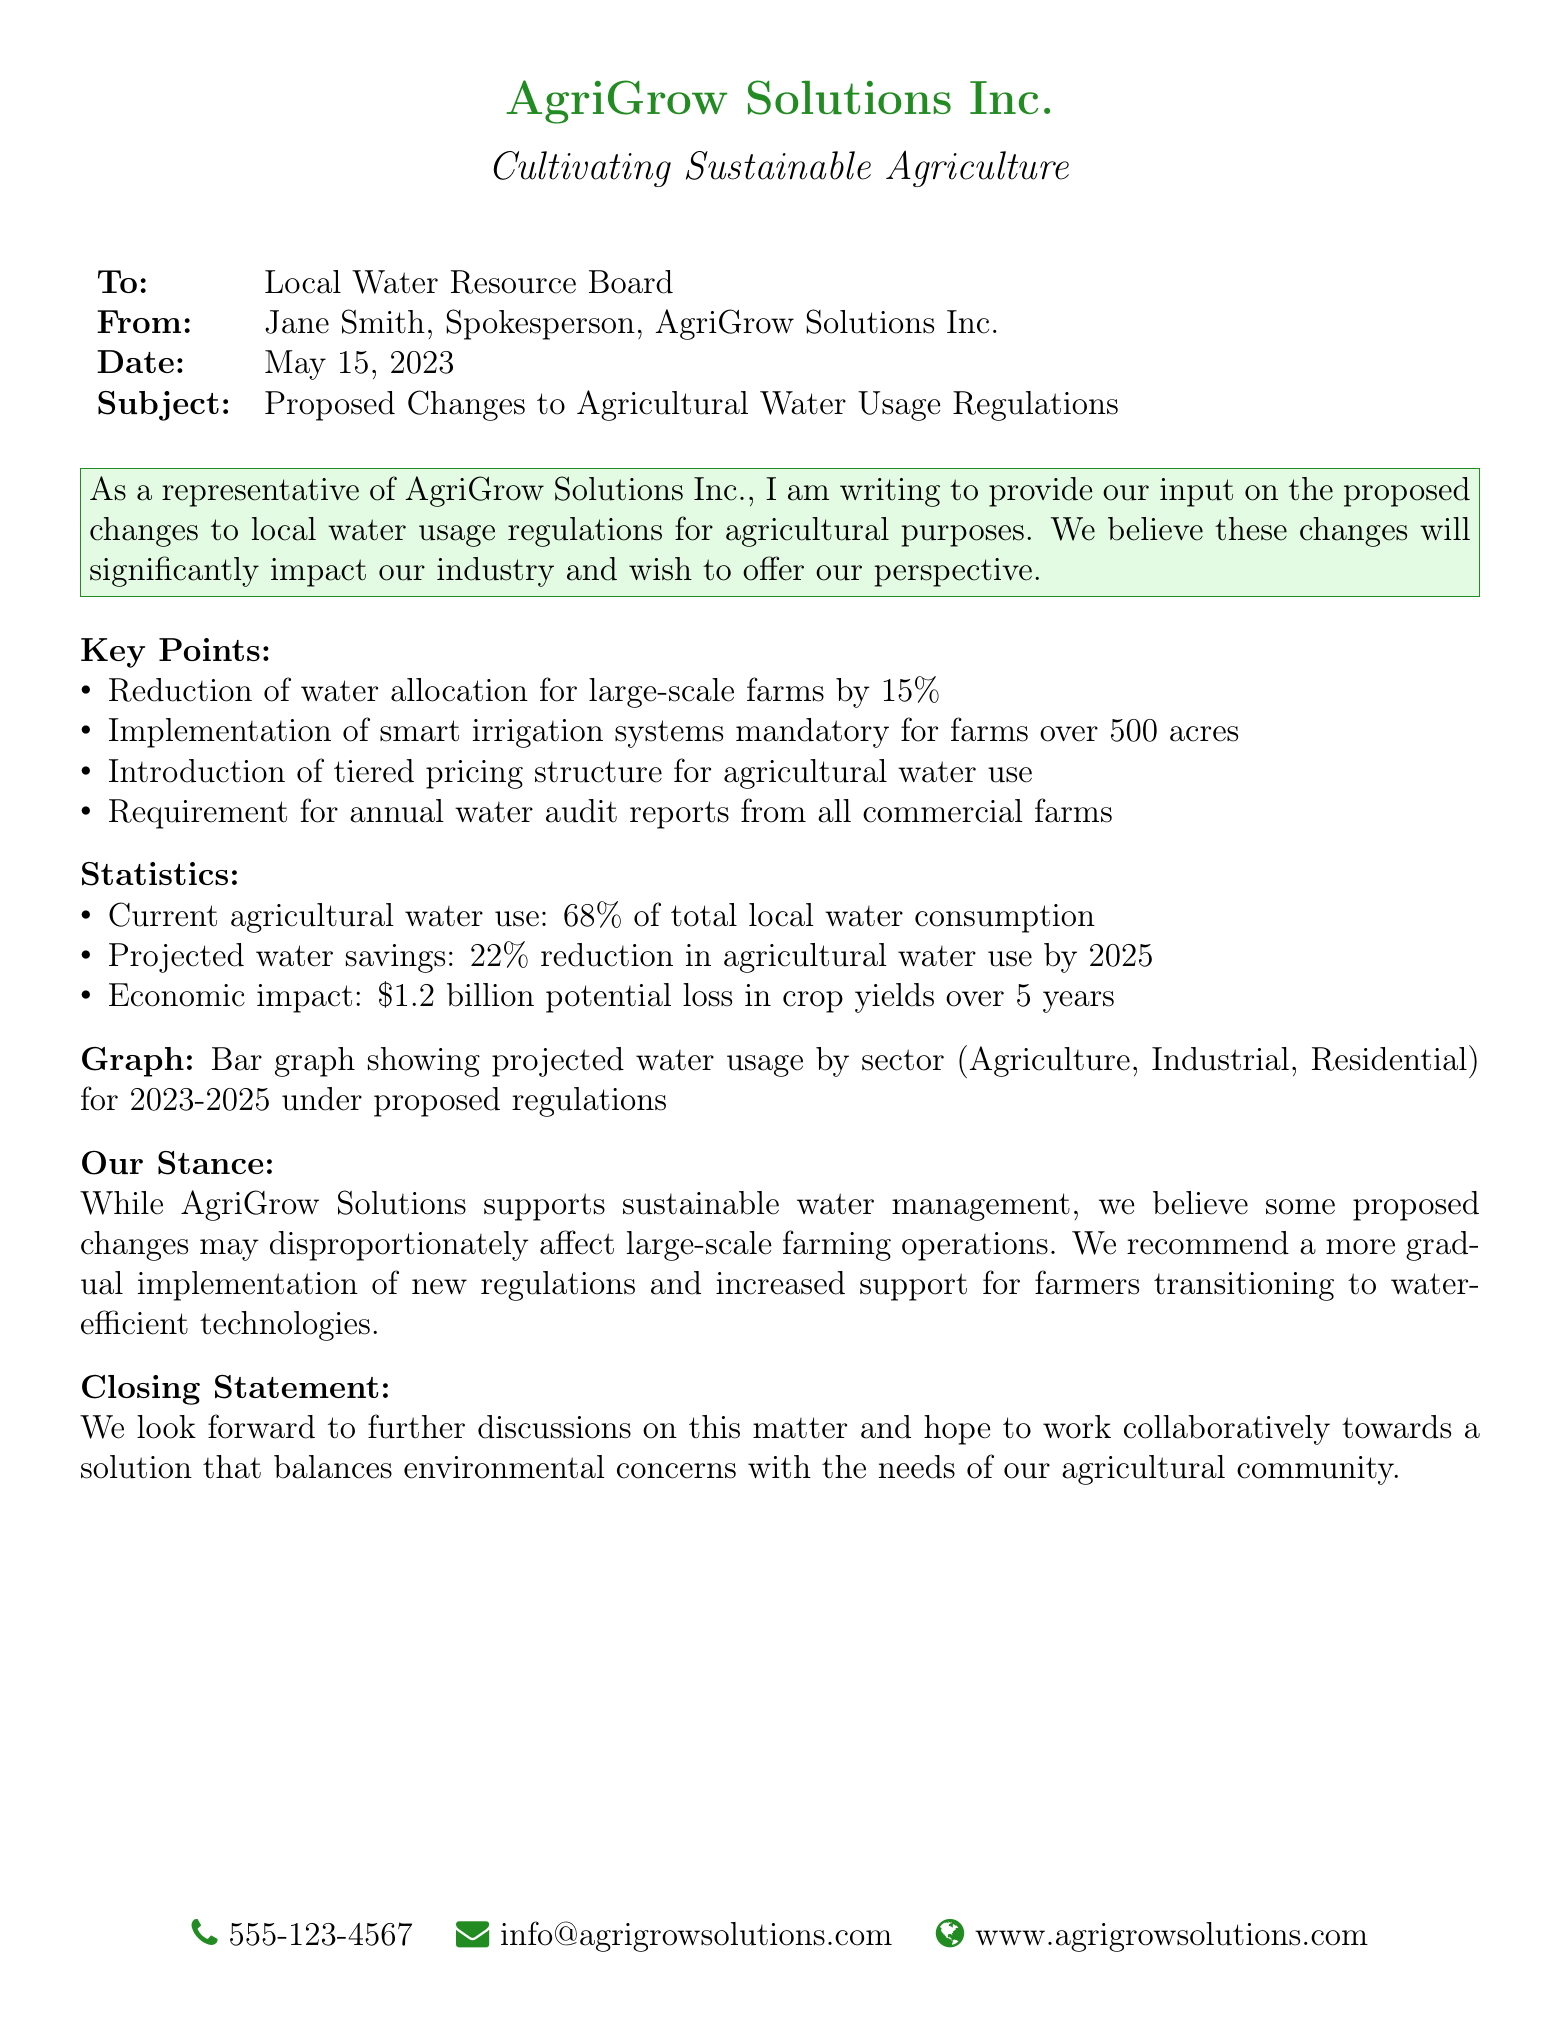what is the date of the document? The date of the document is stated in the header, which is May 15, 2023.
Answer: May 15, 2023 who is the sender of the fax? The sender is identified at the top of the document as Jane Smith, Spokesperson, AgriGrow Solutions Inc.
Answer: Jane Smith what percentage reduction is proposed for large-scale farms' water allocation? The document specifies a 15% reduction in water allocation for large-scale farms.
Answer: 15% what is the current percentage of agricultural water use out of total local water consumption? The current agricultural water use percentage is outlined as 68% of total local water consumption in the statistics section.
Answer: 68% what is the projected reduction in agricultural water use by 2025? The document mentions a projected reduction of 22% in agricultural water use by 2025.
Answer: 22% what economic impact is estimated over 5 years due to the proposed changes? The estimated economic impact due to the changes is detailed as a potential loss of $1.2 billion in crop yields over 5 years.
Answer: $1.2 billion what is the proposed mandatory system for farms over 500 acres? The document states that the implementation of smart irrigation systems is mandatory for farms over 500 acres.
Answer: smart irrigation systems what does AgriGrow Solutions Inc. support regarding water management? The company expresses support for sustainable water management in the document.
Answer: sustainable water management what type of audit is required from all commercial farms? The document indicates that annual water audit reports are required from all commercial farms.
Answer: annual water audit reports 